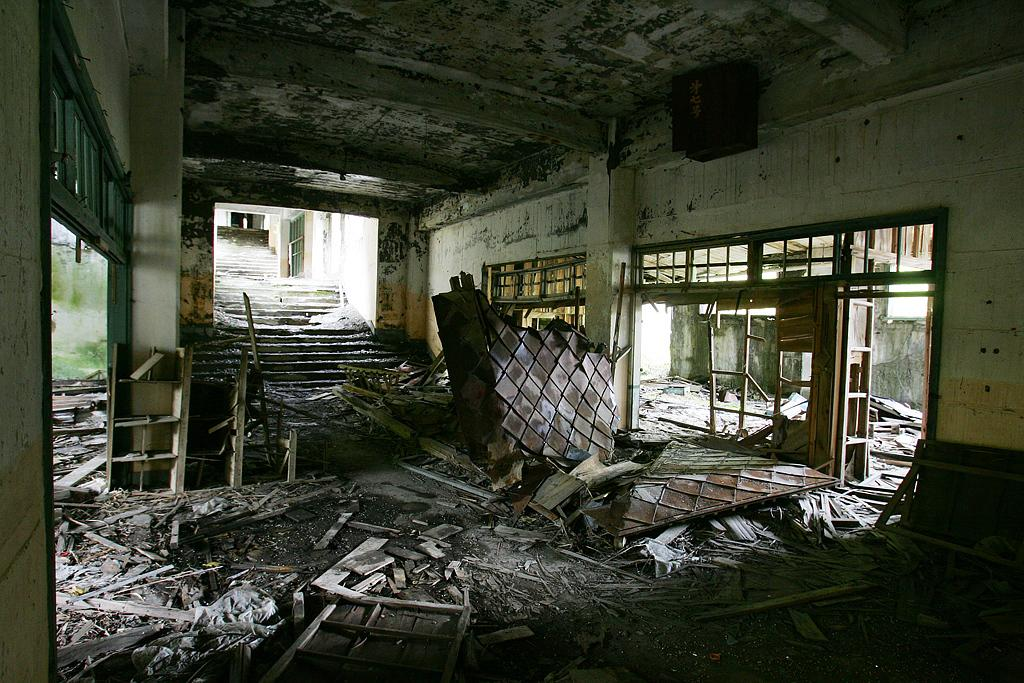What type of location is depicted in the image? The image is taken in an old building. What can be seen at the bottom of the image? There are broken furniture at the bottom of the image. What architectural feature is visible towards the left side of the image? There is a staircase towards the left side of the image. What type of tank is visible in the image? There is no tank present in the image; it is taken in an old building with broken furniture and a staircase. 